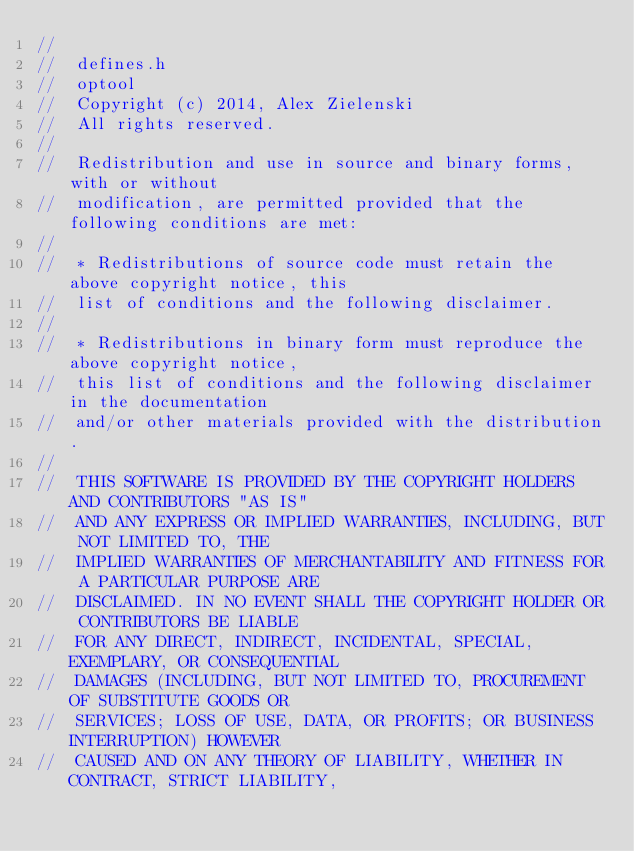<code> <loc_0><loc_0><loc_500><loc_500><_C_>//
//  defines.h
//  optool
//  Copyright (c) 2014, Alex Zielenski
//  All rights reserved.
//
//  Redistribution and use in source and binary forms, with or without
//  modification, are permitted provided that the following conditions are met:
//
//  * Redistributions of source code must retain the above copyright notice, this
//  list of conditions and the following disclaimer.
//
//  * Redistributions in binary form must reproduce the above copyright notice,
//  this list of conditions and the following disclaimer in the documentation
//  and/or other materials provided with the distribution.
//
//  THIS SOFTWARE IS PROVIDED BY THE COPYRIGHT HOLDERS AND CONTRIBUTORS "AS IS"
//  AND ANY EXPRESS OR IMPLIED WARRANTIES, INCLUDING, BUT NOT LIMITED TO, THE
//  IMPLIED WARRANTIES OF MERCHANTABILITY AND FITNESS FOR A PARTICULAR PURPOSE ARE
//  DISCLAIMED. IN NO EVENT SHALL THE COPYRIGHT HOLDER OR CONTRIBUTORS BE LIABLE
//  FOR ANY DIRECT, INDIRECT, INCIDENTAL, SPECIAL, EXEMPLARY, OR CONSEQUENTIAL
//  DAMAGES (INCLUDING, BUT NOT LIMITED TO, PROCUREMENT OF SUBSTITUTE GOODS OR
//  SERVICES; LOSS OF USE, DATA, OR PROFITS; OR BUSINESS INTERRUPTION) HOWEVER
//  CAUSED AND ON ANY THEORY OF LIABILITY, WHETHER IN CONTRACT, STRICT LIABILITY,</code> 